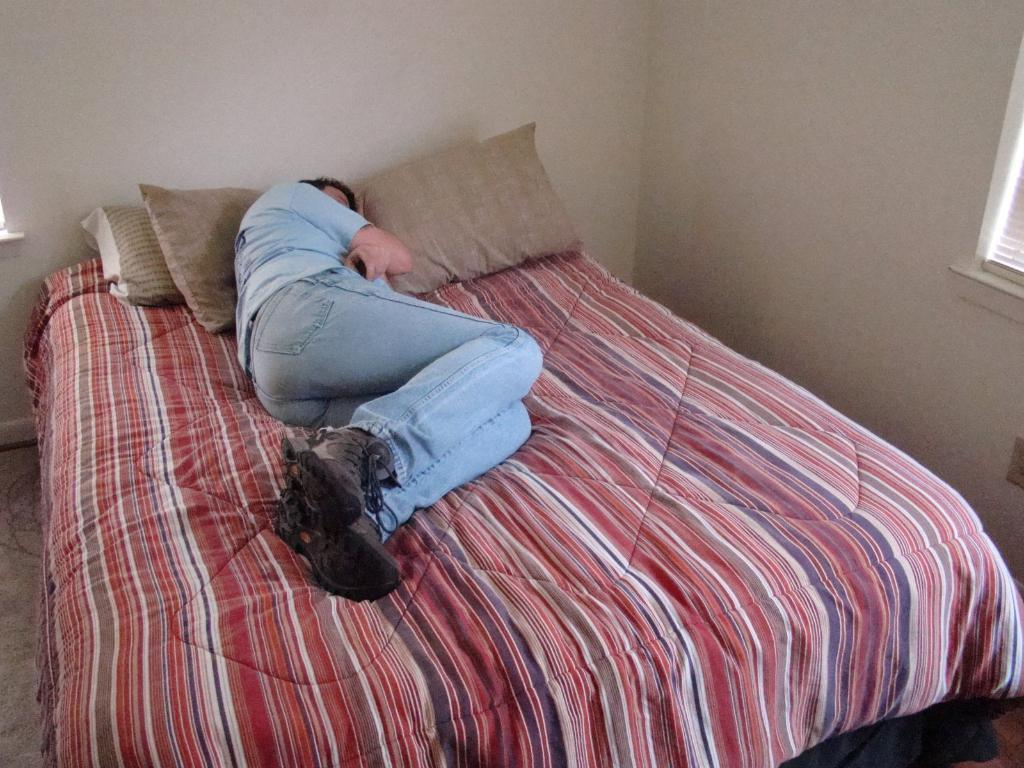What is the man in the image doing? The man is sleeping on the bed. What type of clothing is the man wearing? The man is wearing a T-shirt and trousers. What type of footwear is the man wearing? The man is wearing shoes. What can be found on the bed besides the man? There are pillows on the bed. What is visible in the background of the image? There is a wall in the image, and there might be a window on the right side of the image. What type of yoke is the man holding in the image? There is no yoke present in the image; the man is sleeping on the bed. Can you identify the actor who is playing the role of the man in the image? There is no actor in the image, as it is a photograph of a real person sleeping on a bed. 